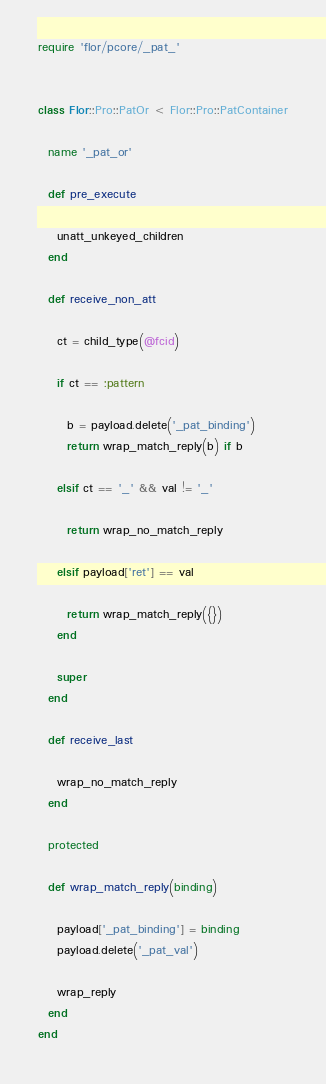Convert code to text. <code><loc_0><loc_0><loc_500><loc_500><_Ruby_>
require 'flor/pcore/_pat_'


class Flor::Pro::PatOr < Flor::Pro::PatContainer

  name '_pat_or'

  def pre_execute

    unatt_unkeyed_children
  end

  def receive_non_att

    ct = child_type(@fcid)

    if ct == :pattern

      b = payload.delete('_pat_binding')
      return wrap_match_reply(b) if b

    elsif ct == '_' && val != '_'

      return wrap_no_match_reply

    elsif payload['ret'] == val

      return wrap_match_reply({})
    end

    super
  end

  def receive_last

    wrap_no_match_reply
  end

  protected

  def wrap_match_reply(binding)

    payload['_pat_binding'] = binding
    payload.delete('_pat_val')

    wrap_reply
  end
end

</code> 